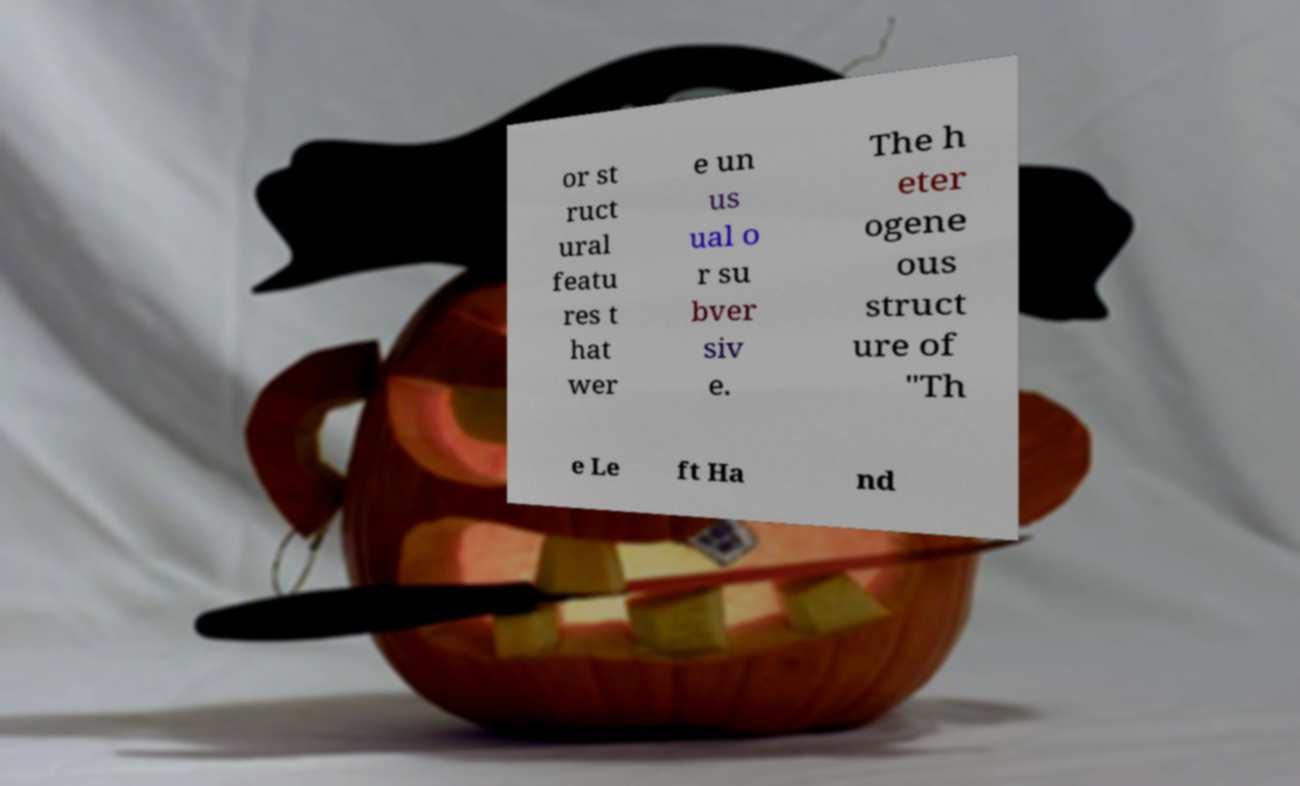Please read and relay the text visible in this image. What does it say? or st ruct ural featu res t hat wer e un us ual o r su bver siv e. The h eter ogene ous struct ure of "Th e Le ft Ha nd 